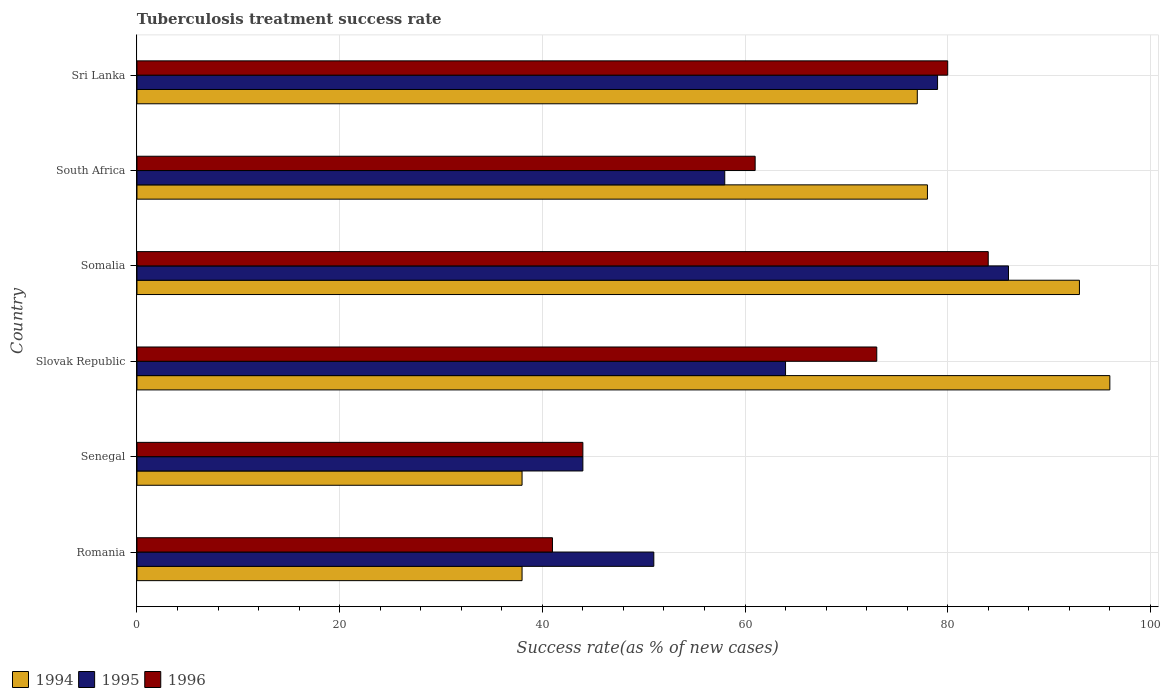How many different coloured bars are there?
Ensure brevity in your answer.  3. Are the number of bars per tick equal to the number of legend labels?
Your response must be concise. Yes. How many bars are there on the 5th tick from the top?
Keep it short and to the point. 3. What is the label of the 6th group of bars from the top?
Make the answer very short. Romania. In how many cases, is the number of bars for a given country not equal to the number of legend labels?
Your answer should be compact. 0. What is the tuberculosis treatment success rate in 1994 in Somalia?
Provide a succinct answer. 93. Across all countries, what is the maximum tuberculosis treatment success rate in 1996?
Offer a terse response. 84. Across all countries, what is the minimum tuberculosis treatment success rate in 1995?
Provide a succinct answer. 44. In which country was the tuberculosis treatment success rate in 1994 maximum?
Your answer should be very brief. Slovak Republic. In which country was the tuberculosis treatment success rate in 1996 minimum?
Your response must be concise. Romania. What is the total tuberculosis treatment success rate in 1994 in the graph?
Give a very brief answer. 420. What is the average tuberculosis treatment success rate in 1995 per country?
Offer a very short reply. 63.67. What is the difference between the tuberculosis treatment success rate in 1995 and tuberculosis treatment success rate in 1994 in Sri Lanka?
Provide a short and direct response. 2. In how many countries, is the tuberculosis treatment success rate in 1995 greater than 76 %?
Give a very brief answer. 2. What is the ratio of the tuberculosis treatment success rate in 1994 in Senegal to that in South Africa?
Offer a very short reply. 0.49. What is the difference between the highest and the lowest tuberculosis treatment success rate in 1996?
Give a very brief answer. 43. In how many countries, is the tuberculosis treatment success rate in 1994 greater than the average tuberculosis treatment success rate in 1994 taken over all countries?
Your response must be concise. 4. What does the 2nd bar from the top in Slovak Republic represents?
Offer a terse response. 1995. Is it the case that in every country, the sum of the tuberculosis treatment success rate in 1994 and tuberculosis treatment success rate in 1996 is greater than the tuberculosis treatment success rate in 1995?
Your answer should be compact. Yes. How many bars are there?
Ensure brevity in your answer.  18. Are all the bars in the graph horizontal?
Keep it short and to the point. Yes. How many countries are there in the graph?
Your answer should be compact. 6. Does the graph contain any zero values?
Provide a short and direct response. No. Does the graph contain grids?
Ensure brevity in your answer.  Yes. Where does the legend appear in the graph?
Provide a succinct answer. Bottom left. How are the legend labels stacked?
Ensure brevity in your answer.  Horizontal. What is the title of the graph?
Offer a very short reply. Tuberculosis treatment success rate. Does "1992" appear as one of the legend labels in the graph?
Provide a succinct answer. No. What is the label or title of the X-axis?
Provide a succinct answer. Success rate(as % of new cases). What is the Success rate(as % of new cases) in 1996 in Romania?
Your answer should be compact. 41. What is the Success rate(as % of new cases) in 1994 in Senegal?
Offer a terse response. 38. What is the Success rate(as % of new cases) of 1996 in Senegal?
Make the answer very short. 44. What is the Success rate(as % of new cases) of 1994 in Slovak Republic?
Make the answer very short. 96. What is the Success rate(as % of new cases) in 1996 in Slovak Republic?
Ensure brevity in your answer.  73. What is the Success rate(as % of new cases) in 1994 in Somalia?
Provide a short and direct response. 93. What is the Success rate(as % of new cases) in 1994 in South Africa?
Keep it short and to the point. 78. What is the Success rate(as % of new cases) of 1995 in South Africa?
Offer a terse response. 58. What is the Success rate(as % of new cases) in 1994 in Sri Lanka?
Keep it short and to the point. 77. What is the Success rate(as % of new cases) of 1995 in Sri Lanka?
Provide a succinct answer. 79. Across all countries, what is the maximum Success rate(as % of new cases) of 1994?
Give a very brief answer. 96. Across all countries, what is the minimum Success rate(as % of new cases) of 1994?
Offer a terse response. 38. Across all countries, what is the minimum Success rate(as % of new cases) in 1996?
Offer a very short reply. 41. What is the total Success rate(as % of new cases) of 1994 in the graph?
Make the answer very short. 420. What is the total Success rate(as % of new cases) in 1995 in the graph?
Make the answer very short. 382. What is the total Success rate(as % of new cases) of 1996 in the graph?
Make the answer very short. 383. What is the difference between the Success rate(as % of new cases) in 1994 in Romania and that in Senegal?
Give a very brief answer. 0. What is the difference between the Success rate(as % of new cases) of 1996 in Romania and that in Senegal?
Provide a succinct answer. -3. What is the difference between the Success rate(as % of new cases) in 1994 in Romania and that in Slovak Republic?
Provide a short and direct response. -58. What is the difference between the Success rate(as % of new cases) of 1996 in Romania and that in Slovak Republic?
Your answer should be compact. -32. What is the difference between the Success rate(as % of new cases) of 1994 in Romania and that in Somalia?
Make the answer very short. -55. What is the difference between the Success rate(as % of new cases) in 1995 in Romania and that in Somalia?
Make the answer very short. -35. What is the difference between the Success rate(as % of new cases) in 1996 in Romania and that in Somalia?
Provide a succinct answer. -43. What is the difference between the Success rate(as % of new cases) of 1994 in Romania and that in Sri Lanka?
Offer a very short reply. -39. What is the difference between the Success rate(as % of new cases) in 1996 in Romania and that in Sri Lanka?
Provide a succinct answer. -39. What is the difference between the Success rate(as % of new cases) in 1994 in Senegal and that in Slovak Republic?
Keep it short and to the point. -58. What is the difference between the Success rate(as % of new cases) of 1994 in Senegal and that in Somalia?
Ensure brevity in your answer.  -55. What is the difference between the Success rate(as % of new cases) in 1995 in Senegal and that in Somalia?
Ensure brevity in your answer.  -42. What is the difference between the Success rate(as % of new cases) in 1996 in Senegal and that in Somalia?
Provide a short and direct response. -40. What is the difference between the Success rate(as % of new cases) of 1994 in Senegal and that in Sri Lanka?
Provide a short and direct response. -39. What is the difference between the Success rate(as % of new cases) in 1995 in Senegal and that in Sri Lanka?
Ensure brevity in your answer.  -35. What is the difference between the Success rate(as % of new cases) in 1996 in Senegal and that in Sri Lanka?
Keep it short and to the point. -36. What is the difference between the Success rate(as % of new cases) in 1995 in Slovak Republic and that in Somalia?
Keep it short and to the point. -22. What is the difference between the Success rate(as % of new cases) in 1996 in Slovak Republic and that in Somalia?
Give a very brief answer. -11. What is the difference between the Success rate(as % of new cases) in 1996 in Slovak Republic and that in South Africa?
Your answer should be compact. 12. What is the difference between the Success rate(as % of new cases) of 1995 in Slovak Republic and that in Sri Lanka?
Your answer should be compact. -15. What is the difference between the Success rate(as % of new cases) in 1994 in South Africa and that in Sri Lanka?
Offer a terse response. 1. What is the difference between the Success rate(as % of new cases) in 1996 in South Africa and that in Sri Lanka?
Offer a terse response. -19. What is the difference between the Success rate(as % of new cases) in 1994 in Romania and the Success rate(as % of new cases) in 1996 in Senegal?
Your answer should be compact. -6. What is the difference between the Success rate(as % of new cases) in 1994 in Romania and the Success rate(as % of new cases) in 1995 in Slovak Republic?
Your response must be concise. -26. What is the difference between the Success rate(as % of new cases) in 1994 in Romania and the Success rate(as % of new cases) in 1996 in Slovak Republic?
Ensure brevity in your answer.  -35. What is the difference between the Success rate(as % of new cases) of 1994 in Romania and the Success rate(as % of new cases) of 1995 in Somalia?
Offer a terse response. -48. What is the difference between the Success rate(as % of new cases) in 1994 in Romania and the Success rate(as % of new cases) in 1996 in Somalia?
Offer a very short reply. -46. What is the difference between the Success rate(as % of new cases) of 1995 in Romania and the Success rate(as % of new cases) of 1996 in Somalia?
Ensure brevity in your answer.  -33. What is the difference between the Success rate(as % of new cases) in 1994 in Romania and the Success rate(as % of new cases) in 1995 in South Africa?
Provide a short and direct response. -20. What is the difference between the Success rate(as % of new cases) in 1994 in Romania and the Success rate(as % of new cases) in 1996 in South Africa?
Your answer should be very brief. -23. What is the difference between the Success rate(as % of new cases) of 1995 in Romania and the Success rate(as % of new cases) of 1996 in South Africa?
Your answer should be compact. -10. What is the difference between the Success rate(as % of new cases) of 1994 in Romania and the Success rate(as % of new cases) of 1995 in Sri Lanka?
Make the answer very short. -41. What is the difference between the Success rate(as % of new cases) in 1994 in Romania and the Success rate(as % of new cases) in 1996 in Sri Lanka?
Ensure brevity in your answer.  -42. What is the difference between the Success rate(as % of new cases) in 1994 in Senegal and the Success rate(as % of new cases) in 1995 in Slovak Republic?
Your response must be concise. -26. What is the difference between the Success rate(as % of new cases) in 1994 in Senegal and the Success rate(as % of new cases) in 1996 in Slovak Republic?
Offer a terse response. -35. What is the difference between the Success rate(as % of new cases) of 1995 in Senegal and the Success rate(as % of new cases) of 1996 in Slovak Republic?
Offer a very short reply. -29. What is the difference between the Success rate(as % of new cases) of 1994 in Senegal and the Success rate(as % of new cases) of 1995 in Somalia?
Provide a short and direct response. -48. What is the difference between the Success rate(as % of new cases) of 1994 in Senegal and the Success rate(as % of new cases) of 1996 in Somalia?
Provide a succinct answer. -46. What is the difference between the Success rate(as % of new cases) in 1994 in Senegal and the Success rate(as % of new cases) in 1995 in South Africa?
Provide a short and direct response. -20. What is the difference between the Success rate(as % of new cases) of 1995 in Senegal and the Success rate(as % of new cases) of 1996 in South Africa?
Keep it short and to the point. -17. What is the difference between the Success rate(as % of new cases) in 1994 in Senegal and the Success rate(as % of new cases) in 1995 in Sri Lanka?
Offer a very short reply. -41. What is the difference between the Success rate(as % of new cases) of 1994 in Senegal and the Success rate(as % of new cases) of 1996 in Sri Lanka?
Your answer should be very brief. -42. What is the difference between the Success rate(as % of new cases) of 1995 in Senegal and the Success rate(as % of new cases) of 1996 in Sri Lanka?
Ensure brevity in your answer.  -36. What is the difference between the Success rate(as % of new cases) of 1994 in Slovak Republic and the Success rate(as % of new cases) of 1995 in Somalia?
Make the answer very short. 10. What is the difference between the Success rate(as % of new cases) in 1994 in Slovak Republic and the Success rate(as % of new cases) in 1996 in South Africa?
Your answer should be very brief. 35. What is the difference between the Success rate(as % of new cases) in 1994 in Slovak Republic and the Success rate(as % of new cases) in 1996 in Sri Lanka?
Provide a succinct answer. 16. What is the difference between the Success rate(as % of new cases) of 1994 in Somalia and the Success rate(as % of new cases) of 1995 in South Africa?
Offer a terse response. 35. What is the difference between the Success rate(as % of new cases) in 1995 in Somalia and the Success rate(as % of new cases) in 1996 in South Africa?
Offer a terse response. 25. What is the difference between the Success rate(as % of new cases) in 1994 in Somalia and the Success rate(as % of new cases) in 1996 in Sri Lanka?
Your answer should be very brief. 13. What is the difference between the Success rate(as % of new cases) in 1994 in South Africa and the Success rate(as % of new cases) in 1996 in Sri Lanka?
Offer a very short reply. -2. What is the difference between the Success rate(as % of new cases) of 1995 in South Africa and the Success rate(as % of new cases) of 1996 in Sri Lanka?
Your response must be concise. -22. What is the average Success rate(as % of new cases) of 1994 per country?
Keep it short and to the point. 70. What is the average Success rate(as % of new cases) of 1995 per country?
Provide a succinct answer. 63.67. What is the average Success rate(as % of new cases) in 1996 per country?
Your answer should be compact. 63.83. What is the difference between the Success rate(as % of new cases) of 1994 and Success rate(as % of new cases) of 1995 in Senegal?
Offer a terse response. -6. What is the difference between the Success rate(as % of new cases) of 1994 and Success rate(as % of new cases) of 1996 in Senegal?
Provide a short and direct response. -6. What is the difference between the Success rate(as % of new cases) of 1995 and Success rate(as % of new cases) of 1996 in Senegal?
Your answer should be very brief. 0. What is the difference between the Success rate(as % of new cases) of 1994 and Success rate(as % of new cases) of 1996 in Somalia?
Provide a short and direct response. 9. What is the ratio of the Success rate(as % of new cases) of 1994 in Romania to that in Senegal?
Make the answer very short. 1. What is the ratio of the Success rate(as % of new cases) in 1995 in Romania to that in Senegal?
Your answer should be very brief. 1.16. What is the ratio of the Success rate(as % of new cases) in 1996 in Romania to that in Senegal?
Ensure brevity in your answer.  0.93. What is the ratio of the Success rate(as % of new cases) in 1994 in Romania to that in Slovak Republic?
Provide a succinct answer. 0.4. What is the ratio of the Success rate(as % of new cases) in 1995 in Romania to that in Slovak Republic?
Offer a very short reply. 0.8. What is the ratio of the Success rate(as % of new cases) of 1996 in Romania to that in Slovak Republic?
Ensure brevity in your answer.  0.56. What is the ratio of the Success rate(as % of new cases) in 1994 in Romania to that in Somalia?
Ensure brevity in your answer.  0.41. What is the ratio of the Success rate(as % of new cases) in 1995 in Romania to that in Somalia?
Offer a very short reply. 0.59. What is the ratio of the Success rate(as % of new cases) in 1996 in Romania to that in Somalia?
Your answer should be very brief. 0.49. What is the ratio of the Success rate(as % of new cases) in 1994 in Romania to that in South Africa?
Offer a terse response. 0.49. What is the ratio of the Success rate(as % of new cases) of 1995 in Romania to that in South Africa?
Your answer should be compact. 0.88. What is the ratio of the Success rate(as % of new cases) of 1996 in Romania to that in South Africa?
Provide a succinct answer. 0.67. What is the ratio of the Success rate(as % of new cases) in 1994 in Romania to that in Sri Lanka?
Your answer should be compact. 0.49. What is the ratio of the Success rate(as % of new cases) of 1995 in Romania to that in Sri Lanka?
Provide a short and direct response. 0.65. What is the ratio of the Success rate(as % of new cases) in 1996 in Romania to that in Sri Lanka?
Make the answer very short. 0.51. What is the ratio of the Success rate(as % of new cases) in 1994 in Senegal to that in Slovak Republic?
Provide a short and direct response. 0.4. What is the ratio of the Success rate(as % of new cases) in 1995 in Senegal to that in Slovak Republic?
Offer a very short reply. 0.69. What is the ratio of the Success rate(as % of new cases) in 1996 in Senegal to that in Slovak Republic?
Provide a succinct answer. 0.6. What is the ratio of the Success rate(as % of new cases) in 1994 in Senegal to that in Somalia?
Your answer should be compact. 0.41. What is the ratio of the Success rate(as % of new cases) in 1995 in Senegal to that in Somalia?
Ensure brevity in your answer.  0.51. What is the ratio of the Success rate(as % of new cases) in 1996 in Senegal to that in Somalia?
Give a very brief answer. 0.52. What is the ratio of the Success rate(as % of new cases) of 1994 in Senegal to that in South Africa?
Provide a short and direct response. 0.49. What is the ratio of the Success rate(as % of new cases) of 1995 in Senegal to that in South Africa?
Make the answer very short. 0.76. What is the ratio of the Success rate(as % of new cases) in 1996 in Senegal to that in South Africa?
Offer a terse response. 0.72. What is the ratio of the Success rate(as % of new cases) in 1994 in Senegal to that in Sri Lanka?
Make the answer very short. 0.49. What is the ratio of the Success rate(as % of new cases) of 1995 in Senegal to that in Sri Lanka?
Offer a terse response. 0.56. What is the ratio of the Success rate(as % of new cases) of 1996 in Senegal to that in Sri Lanka?
Offer a very short reply. 0.55. What is the ratio of the Success rate(as % of new cases) of 1994 in Slovak Republic to that in Somalia?
Offer a terse response. 1.03. What is the ratio of the Success rate(as % of new cases) of 1995 in Slovak Republic to that in Somalia?
Your response must be concise. 0.74. What is the ratio of the Success rate(as % of new cases) in 1996 in Slovak Republic to that in Somalia?
Offer a terse response. 0.87. What is the ratio of the Success rate(as % of new cases) of 1994 in Slovak Republic to that in South Africa?
Give a very brief answer. 1.23. What is the ratio of the Success rate(as % of new cases) in 1995 in Slovak Republic to that in South Africa?
Give a very brief answer. 1.1. What is the ratio of the Success rate(as % of new cases) in 1996 in Slovak Republic to that in South Africa?
Offer a very short reply. 1.2. What is the ratio of the Success rate(as % of new cases) in 1994 in Slovak Republic to that in Sri Lanka?
Your answer should be very brief. 1.25. What is the ratio of the Success rate(as % of new cases) in 1995 in Slovak Republic to that in Sri Lanka?
Provide a succinct answer. 0.81. What is the ratio of the Success rate(as % of new cases) in 1996 in Slovak Republic to that in Sri Lanka?
Give a very brief answer. 0.91. What is the ratio of the Success rate(as % of new cases) in 1994 in Somalia to that in South Africa?
Your answer should be very brief. 1.19. What is the ratio of the Success rate(as % of new cases) of 1995 in Somalia to that in South Africa?
Keep it short and to the point. 1.48. What is the ratio of the Success rate(as % of new cases) in 1996 in Somalia to that in South Africa?
Give a very brief answer. 1.38. What is the ratio of the Success rate(as % of new cases) in 1994 in Somalia to that in Sri Lanka?
Provide a short and direct response. 1.21. What is the ratio of the Success rate(as % of new cases) of 1995 in Somalia to that in Sri Lanka?
Provide a short and direct response. 1.09. What is the ratio of the Success rate(as % of new cases) in 1994 in South Africa to that in Sri Lanka?
Your response must be concise. 1.01. What is the ratio of the Success rate(as % of new cases) of 1995 in South Africa to that in Sri Lanka?
Provide a short and direct response. 0.73. What is the ratio of the Success rate(as % of new cases) of 1996 in South Africa to that in Sri Lanka?
Your answer should be compact. 0.76. What is the difference between the highest and the second highest Success rate(as % of new cases) of 1996?
Make the answer very short. 4. 